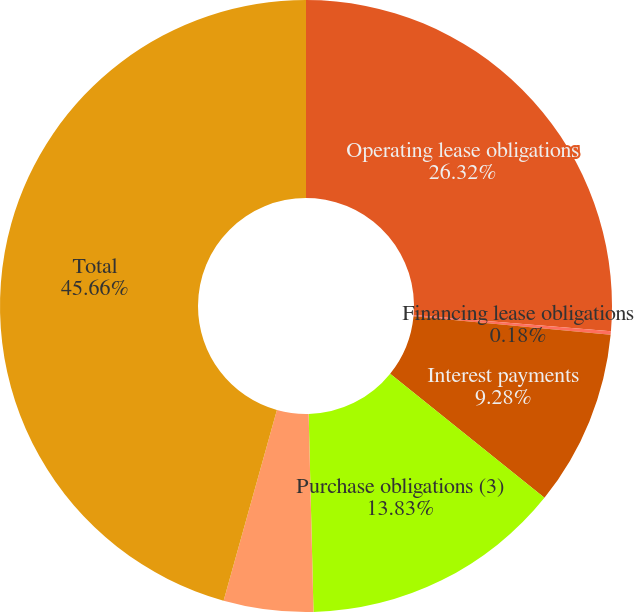Convert chart. <chart><loc_0><loc_0><loc_500><loc_500><pie_chart><fcel>Operating lease obligations<fcel>Financing lease obligations<fcel>Interest payments<fcel>Purchase obligations (3)<fcel>Other obligations (4)<fcel>Total<nl><fcel>26.32%<fcel>0.18%<fcel>9.28%<fcel>13.83%<fcel>4.73%<fcel>45.66%<nl></chart> 